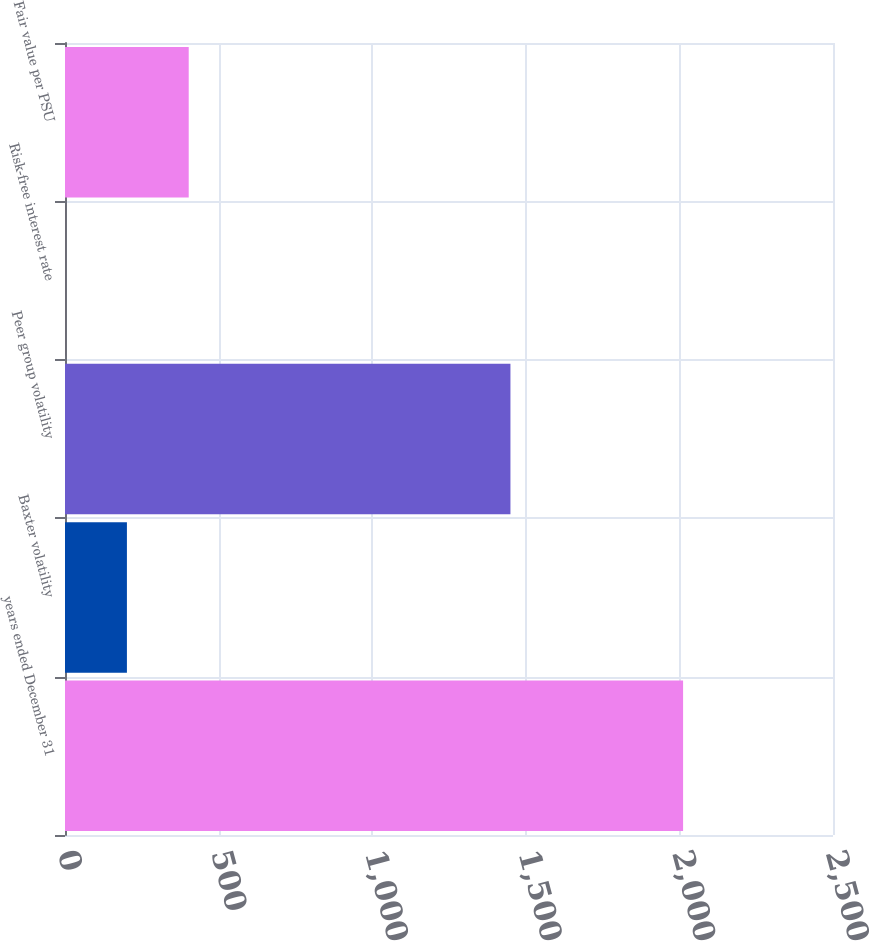Convert chart. <chart><loc_0><loc_0><loc_500><loc_500><bar_chart><fcel>years ended December 31<fcel>Baxter volatility<fcel>Peer group volatility<fcel>Risk-free interest rate<fcel>Fair value per PSU<nl><fcel>2012<fcel>201.56<fcel>1450<fcel>0.4<fcel>402.72<nl></chart> 